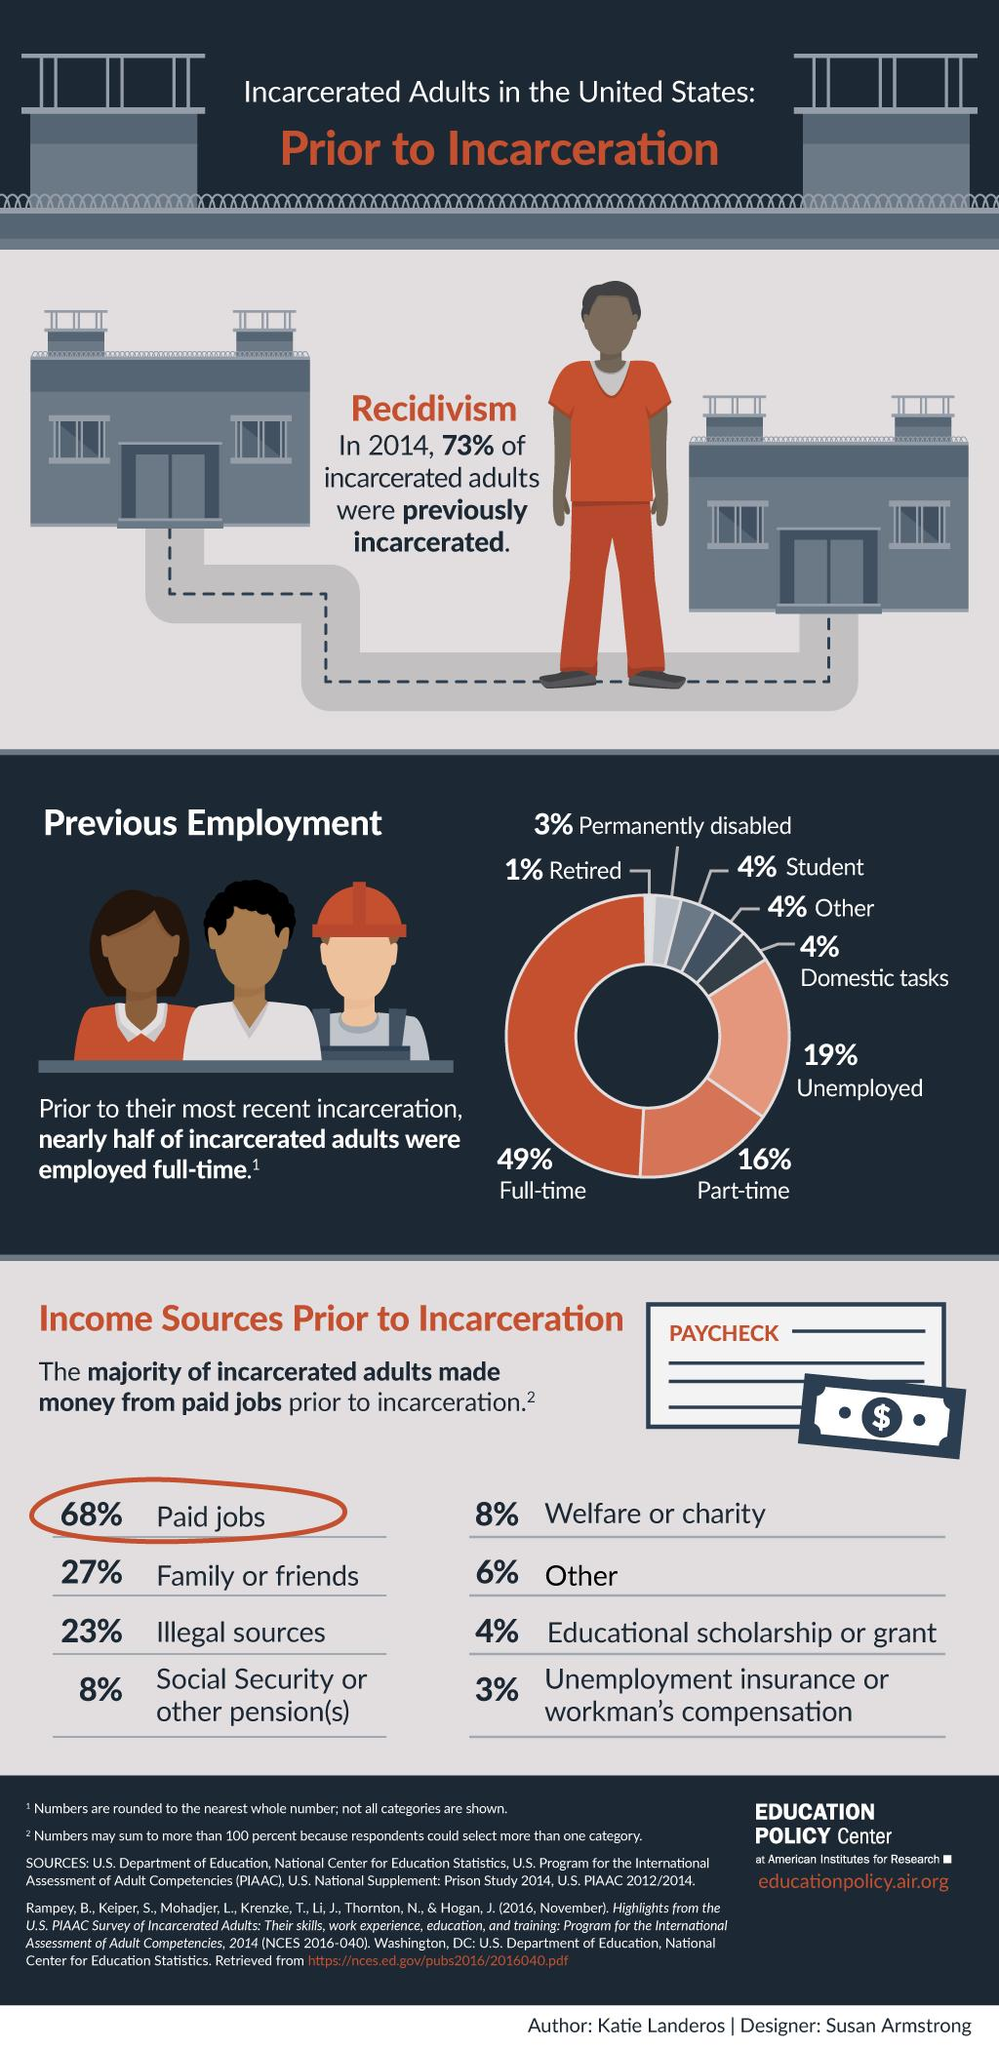Give some essential details in this illustration. The second highest percentage of incarcerated adults in the chart is 16%. The chart shows the percentage of incarcerated adults in different countries, with the second lowest percentage being 3%. According to data, a significant percentage of incarcerated adults are composed of individuals who are students, others, and those who perform domestic tasks, with 12% of the total incarcerated population falling under these categories. Prior to incarceration, the individual's income was primarily derived from grants, amounting to approximately 10% of their total income. Before incarceration, the individual's income was derived from both legal and illegal sources, with a total percentage of 31%. A significant portion of their income was also derived from charitable sources. 